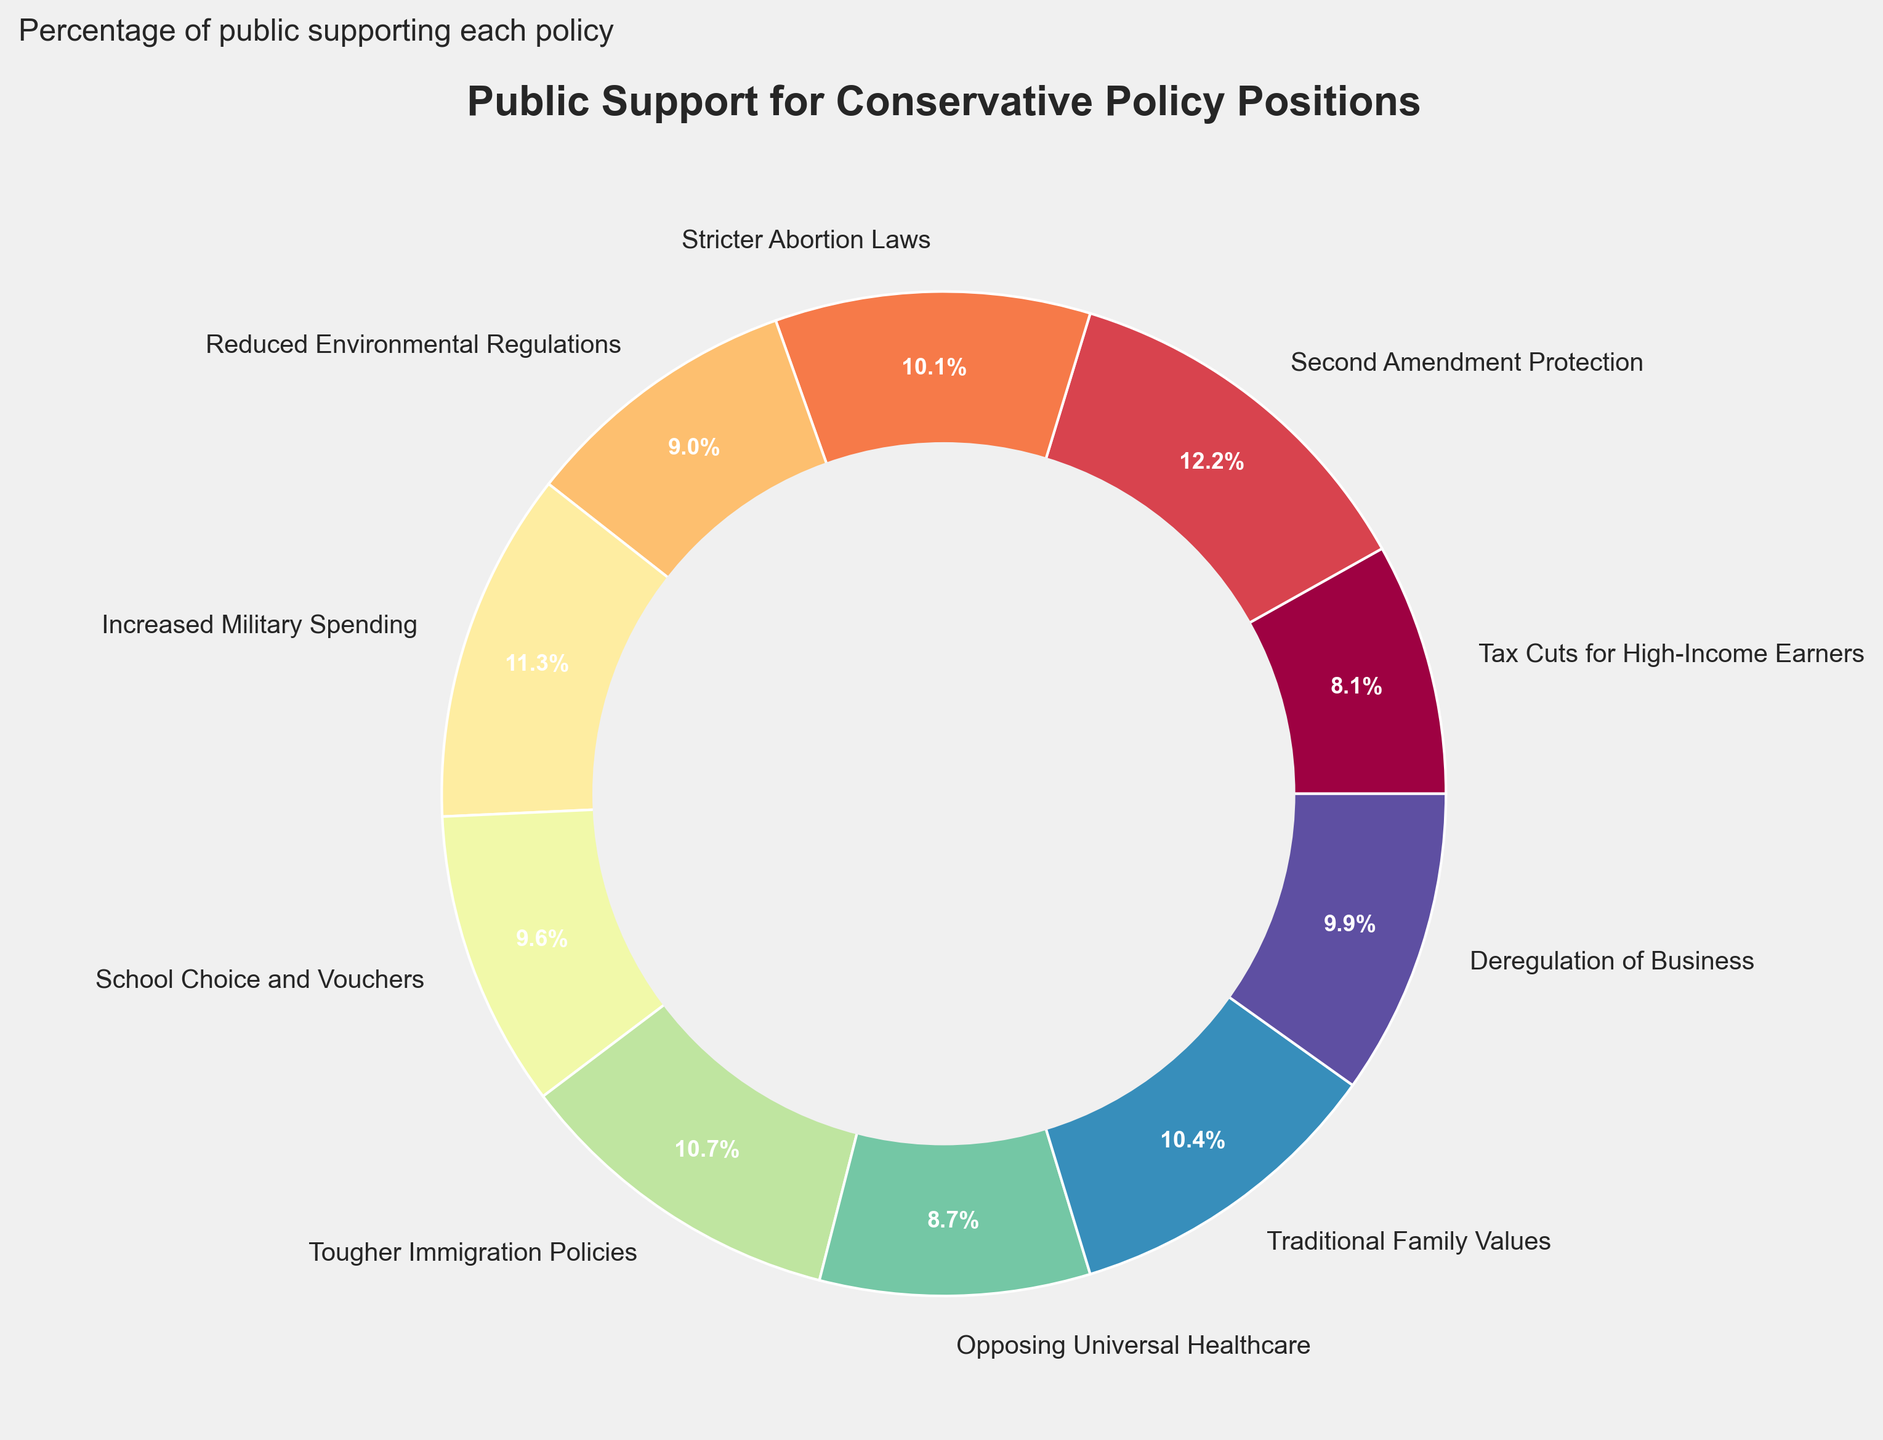What percentage of the public supports stricter abortion laws? To determine the support percentage for stricter abortion laws, locate the segment labeled "Stricter Abortion Laws" on the pie chart and read the value shown for it.
Answer: 35% Which policy position has the highest public support? Identify the largest segment of the pie chart by visual inspection and read the label and the corresponding percentage.
Answer: Second Amendment Protection (42%) What is the difference in support percentage between tax cuts for high-income earners and tougher immigration policies? Locate the segments for "Tax Cuts for High-Income Earners" and "Tougher Immigration Policies," note their support percentages (28% and 37%, respectively), and calculate the difference.
Answer: 9% What is the combined support percentage for policies related to education and business regulation? Identify the segments for "School Choice and Vouchers" (33%) and "Deregulation of Business" (34%), add these two percentages together.
Answer: 67% What policy position receives more support: reduced environmental regulations or increased military spending? Compare the segments labeled "Reduced Environmental Regulations" (31%) and "Increased Military Spending" (39%) by their sizes and percentages.
Answer: Increased Military Spending (39%) What is the average support percentage for the policies listed on the chart? Add together all the support percentages from the pie chart (28+42+35+31+39+33+37+30+36+34) and divide by the number of policies (10).
Answer: 34.5% How does the support for opposing universal healthcare compare visually with the support for traditional family values? Locate the segments for "Opposing Universal Healthcare" and "Traditional Family Values," noticing that the segment for "Traditional Family Values" (36%) is slightly larger than "Opposing Universal Healthcare" (30%).
Answer: Traditional Family Values has more support Rank the policies based on their support percentage from highest to lowest. Sort the policies by their support percentages listed on the chart: 
1. Second Amendment Protection (42%)
2. Increased Military Spending (39%)
3. Tougher Immigration Policies (37%)
4. Traditional Family Values (36%)
5. Stricter Abortion Laws (35%)
6. Deregulation of Business (34%)
7. School Choice and Vouchers (33%)
8. Reduced Environmental Regulations (31%)
9. Opposing Universal Healthcare (30%)
10. Tax Cuts for High-Income Earners (28%)
Answer: Ordered list with Second Amendment Protection at top and Tax Cuts for High-Income Earners at bottom Which educational and family-related policies are more supported by the public? Compare the support percentages for "School Choice and Vouchers" (33%) and "Traditional Family Values" (36%), noting that "Traditional Family Values" has more support.
Answer: Traditional Family Values (36%) 